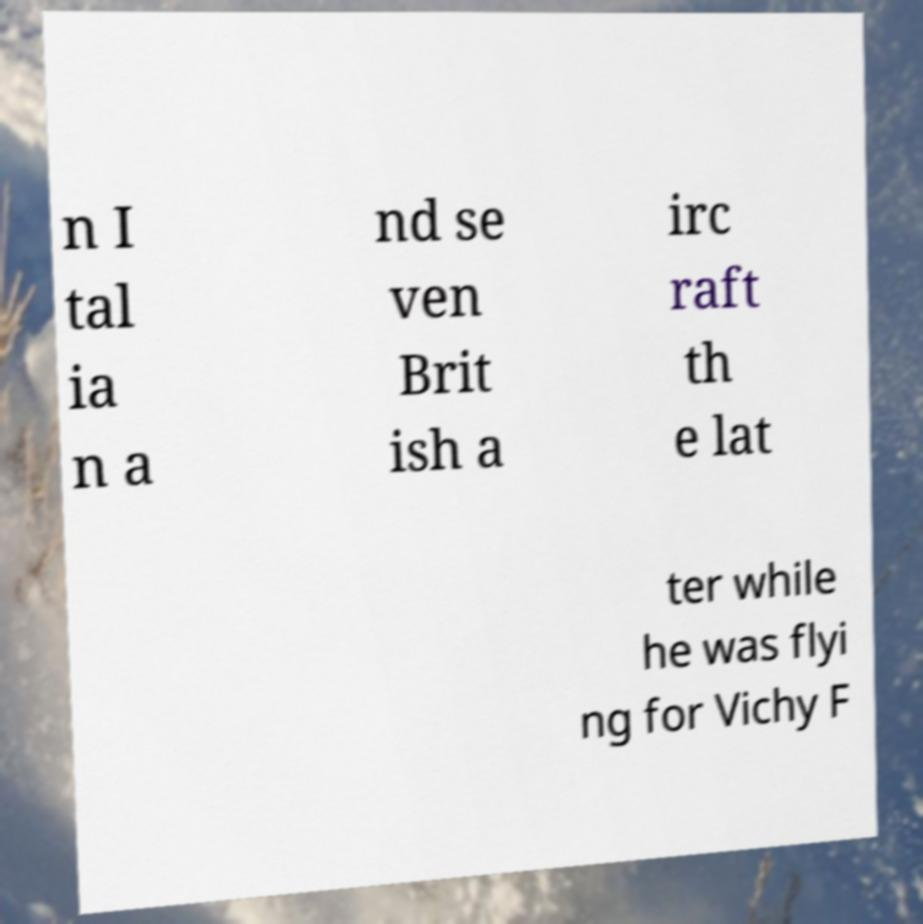There's text embedded in this image that I need extracted. Can you transcribe it verbatim? n I tal ia n a nd se ven Brit ish a irc raft th e lat ter while he was flyi ng for Vichy F 